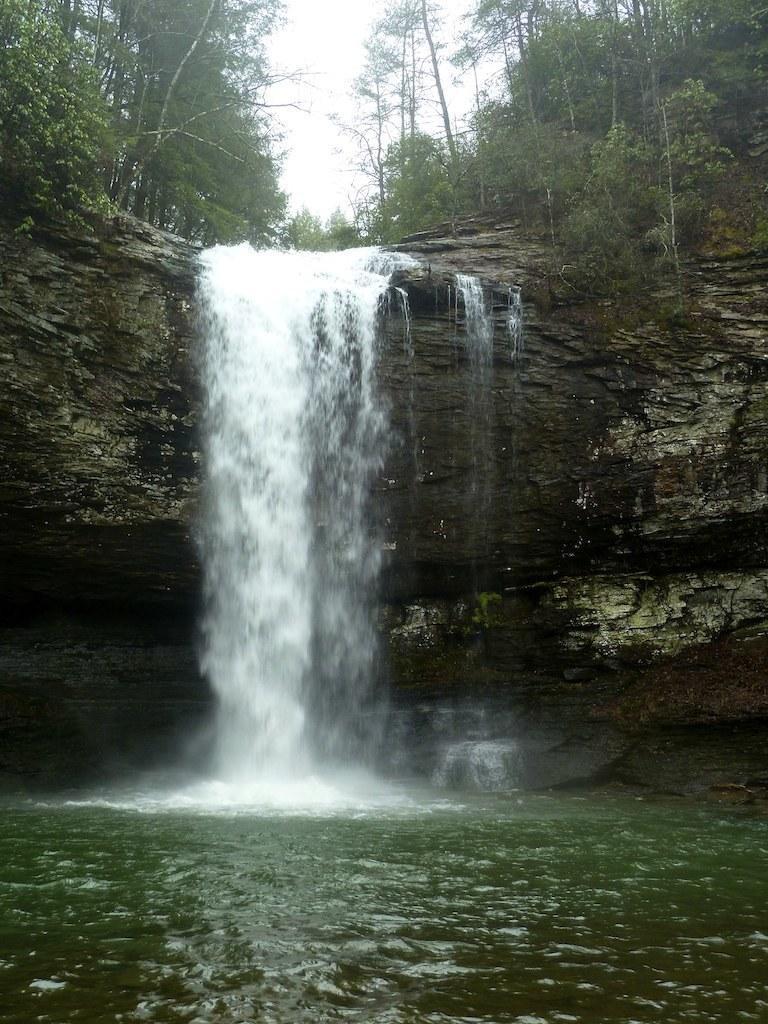Please provide a concise description of this image. In this picture we can see a waterfall and behind the waterfall there are trees and a sky. 